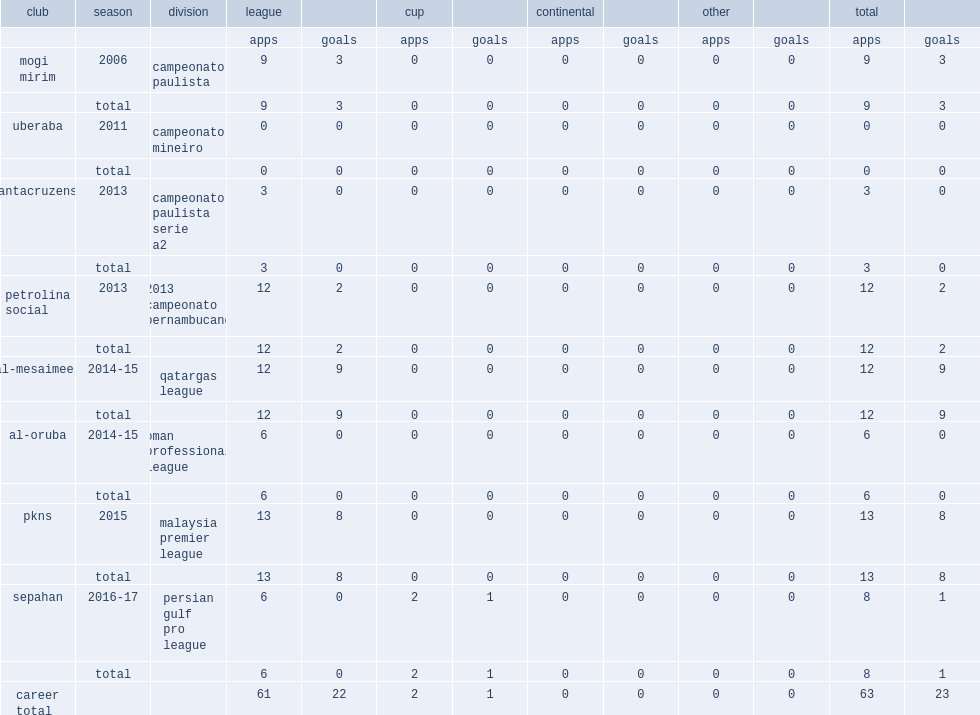Which club did pedro henrique oliveira join in 2011? Uberaba. 